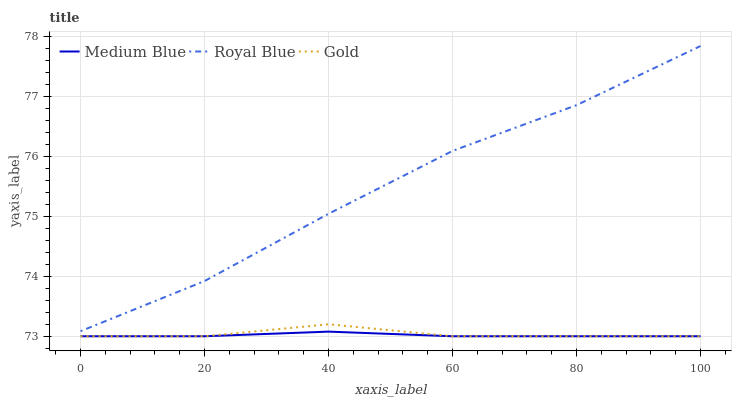Does Medium Blue have the minimum area under the curve?
Answer yes or no. Yes. Does Royal Blue have the maximum area under the curve?
Answer yes or no. Yes. Does Gold have the minimum area under the curve?
Answer yes or no. No. Does Gold have the maximum area under the curve?
Answer yes or no. No. Is Medium Blue the smoothest?
Answer yes or no. Yes. Is Royal Blue the roughest?
Answer yes or no. Yes. Is Gold the smoothest?
Answer yes or no. No. Is Gold the roughest?
Answer yes or no. No. Does Medium Blue have the lowest value?
Answer yes or no. Yes. Does Royal Blue have the highest value?
Answer yes or no. Yes. Does Gold have the highest value?
Answer yes or no. No. Is Gold less than Royal Blue?
Answer yes or no. Yes. Is Royal Blue greater than Medium Blue?
Answer yes or no. Yes. Does Medium Blue intersect Gold?
Answer yes or no. Yes. Is Medium Blue less than Gold?
Answer yes or no. No. Is Medium Blue greater than Gold?
Answer yes or no. No. Does Gold intersect Royal Blue?
Answer yes or no. No. 